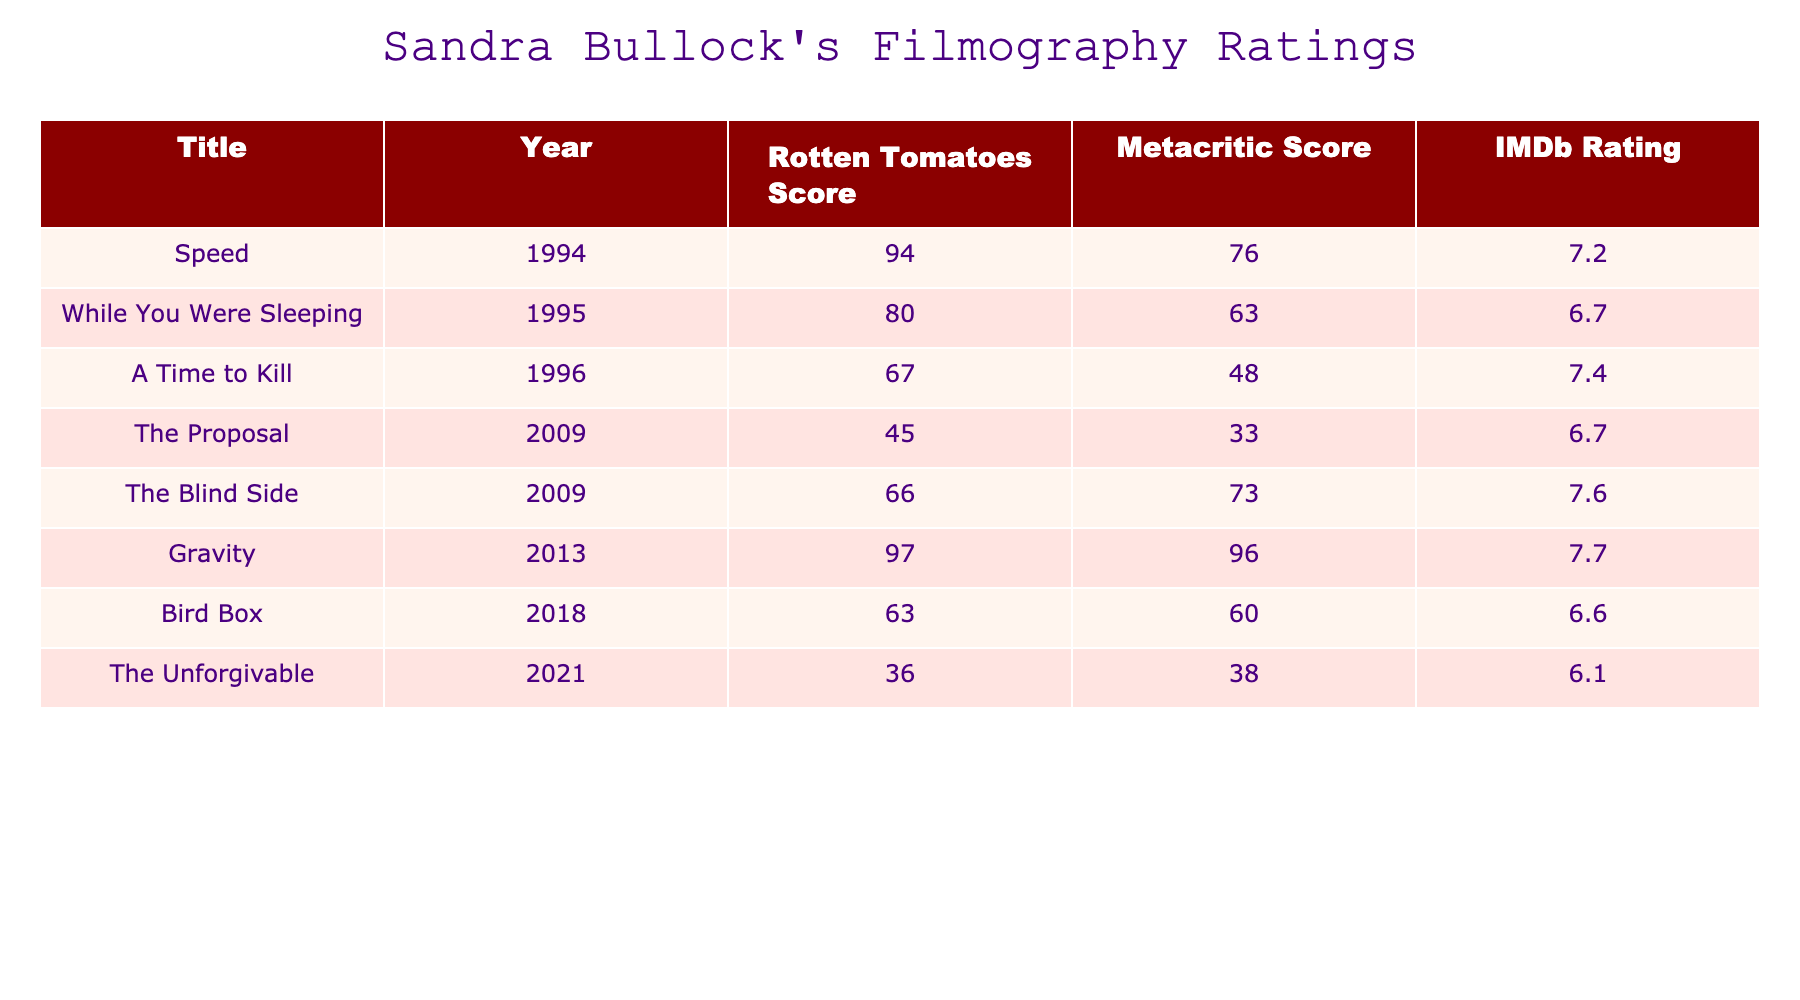What is the Rotten Tomatoes score for "Gravity"? The Rotten Tomatoes score for "Gravity" is listed in the table under the corresponding column, which shows a score of 97%.
Answer: 97% Which film released in 2009 has the highest IMDb rating? In 2009, two films are listed: "The Proposal" with a rating of 6.7 and "The Blind Side" with a rating of 7.6. Comparing these two ratings, "The Blind Side" has the highest IMDb rating of 7.6.
Answer: The Blind Side What is the average Metacritic score of all the films listed? First, we add the Metacritic scores: 76 + 63 + 48 + 33 + 73 + 96 + 60 + 38 = 487. There are 8 films in total, so the average is calculated as 487 / 8 = 60.875, which rounds to 60.9.
Answer: 60.9 Is "While You Were Sleeping" rated above 70% on Rotten Tomatoes? According to the table, "While You Were Sleeping" has a Rotten Tomatoes score of 80%. Since 80% is greater than 70%, the statement is true.
Answer: Yes Which film has the lowest Rotten Tomatoes score among all listed? The Rotten Tomatoes scores for all films are compared: 94%, 80%, 67%, 45%, 66%, 97%, 63%, and 36%. The lowest score is 36% for "The Unforgivable".
Answer: The Unforgivable How many films have an IMDb rating above 7.0? We assess the IMDb ratings for all films: 7.2, 6.7, 7.4, 6.7, 7.6, 7.7, 6.6, and 6.1. The films with ratings above 7.0 are "Speed", "A Time to Kill", "The Blind Side", and "Gravity". Thus 4 films have ratings above 7.0.
Answer: 4 Which movie had the highest Rotten Tomatoes score, and what was its score? Looking through the Rotten Tomatoes scores, we find "Gravity" with a score of 97%, which is the highest score in the table compared to other films listed.
Answer: Gravity, 97% What is the difference between the highest and lowest Metacritic scores? The Metacritic scores in the table are: 76, 63, 48, 33, 73, 96, 60, and 38. The highest score is 96 (from "Gravity"), and the lowest is 33 (from "The Proposal"). The difference is calculated as 96 - 33 = 63.
Answer: 63 